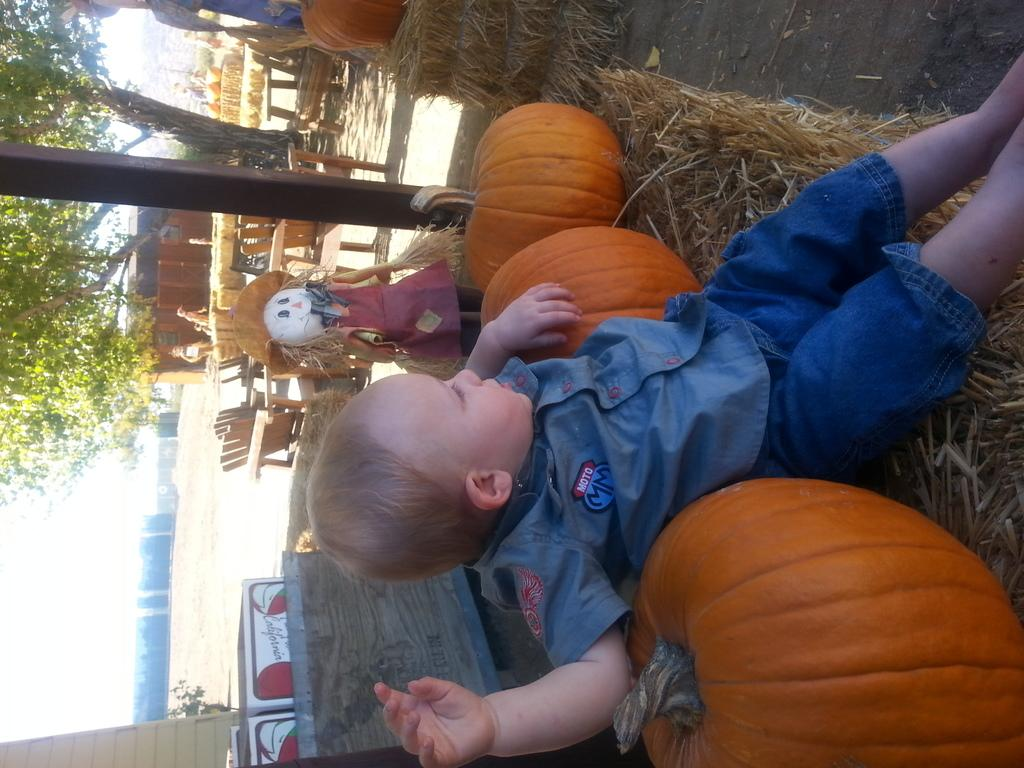What is the main subject of the image? There is a boy sitting in the center of the image. What objects are next to the boy? There are pumpkins next to the boy. What other figure is present in the image? There is a scarecrow next to the pumpkins. What can be seen in the background of the image? There are trees, a pole, and chairs in the background of the image. What additional object is present in the image? There is a board in the image. Can you tell me how many bananas are hanging from the scarecrow in the image? There are no bananas present in the image; only pumpkins and a scarecrow are visible. Is there an owl perched on the board in the image? There is no owl present in the image; only the boy, pumpkins, scarecrow, trees, pole, chairs, and board are visible. 